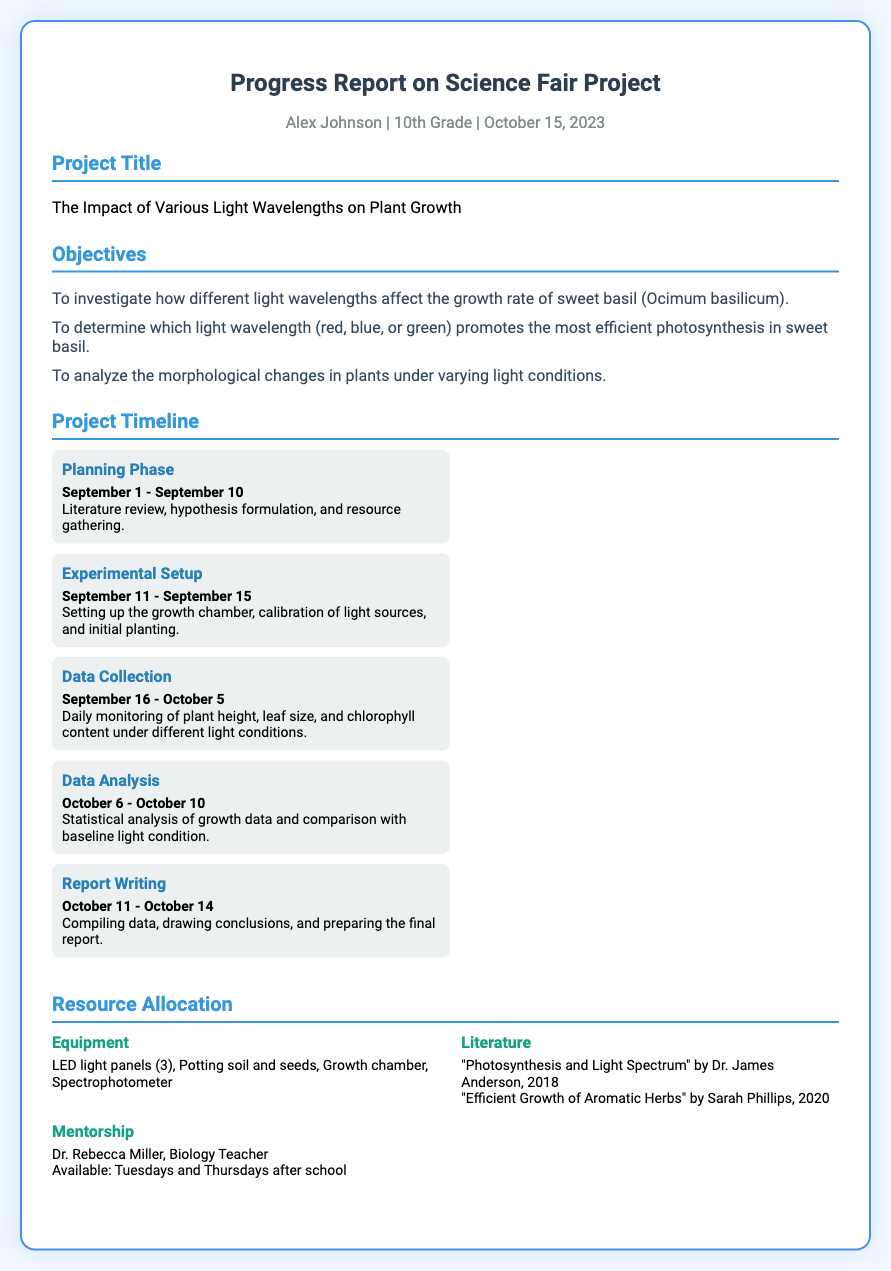what is the student's name? The student's name is mentioned in the header section of the document.
Answer: Alex Johnson what is the project title? The title of the project is specified in the project title section.
Answer: The Impact of Various Light Wavelengths on Plant Growth what is the date range for the Data Collection phase? This information is found in the Project Timeline section, indicating the specific dates for each phase.
Answer: September 16 - October 5 who is the mentor for this project? The mentor's name is provided in the Resource Allocation section.
Answer: Dr. Rebecca Miller what is one of the objectives of the project? The objectives are listed in the Objectives section, and any of them can be an answer.
Answer: To investigate how different light wavelengths affect the growth rate of sweet basil how many LED light panels are allocated for the project? The number of LED light panels is mentioned in the Resource Allocation section under Equipment.
Answer: 3 what dates are designated for Report Writing? The specific dates for Report Writing are found in the Project Timeline section.
Answer: October 11 - October 14 which book was referenced for literature? The literature reference is included in the Resource Allocation section.
Answer: "Photosynthesis and Light Spectrum" by Dr. James Anderson, 2018 what is the duration of the Experimental Setup phase? The duration can be calculated from the dates provided in the Project Timeline.
Answer: 5 days 